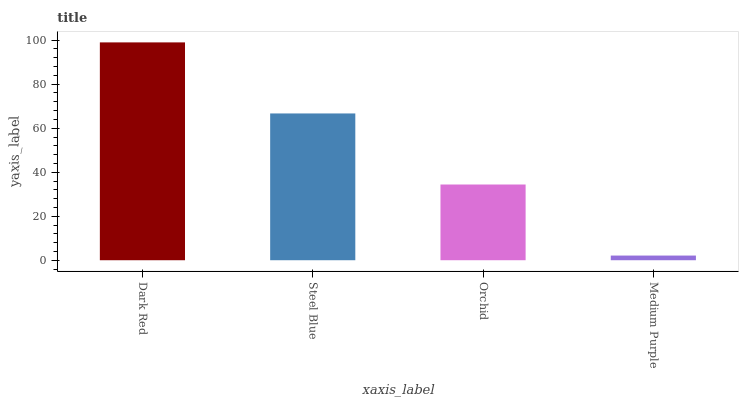Is Medium Purple the minimum?
Answer yes or no. Yes. Is Dark Red the maximum?
Answer yes or no. Yes. Is Steel Blue the minimum?
Answer yes or no. No. Is Steel Blue the maximum?
Answer yes or no. No. Is Dark Red greater than Steel Blue?
Answer yes or no. Yes. Is Steel Blue less than Dark Red?
Answer yes or no. Yes. Is Steel Blue greater than Dark Red?
Answer yes or no. No. Is Dark Red less than Steel Blue?
Answer yes or no. No. Is Steel Blue the high median?
Answer yes or no. Yes. Is Orchid the low median?
Answer yes or no. Yes. Is Medium Purple the high median?
Answer yes or no. No. Is Medium Purple the low median?
Answer yes or no. No. 